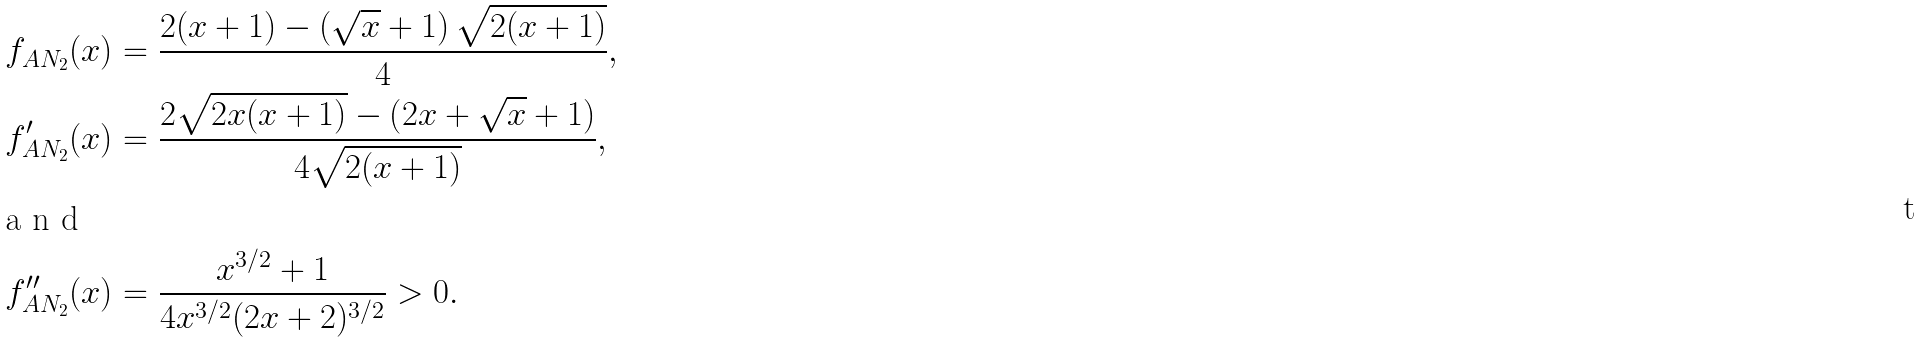<formula> <loc_0><loc_0><loc_500><loc_500>f _ { A N _ { 2 } } ( x ) & = \frac { 2 ( x + 1 ) - \left ( { \sqrt { x } + 1 } \right ) \sqrt { 2 ( x + 1 ) } } { 4 } , \\ { f } ^ { \prime } _ { A N _ { 2 } } ( x ) & = \frac { 2 \sqrt { 2 x ( x + 1 ) } - \left ( { 2 x + \sqrt { x } + 1 } \right ) } { 4 \sqrt { 2 ( x + 1 ) } } , \intertext { a n d } { f } ^ { \prime \prime } _ { A N _ { 2 } } ( x ) & = \frac { x ^ { 3 / 2 } + 1 } { 4 x ^ { 3 / 2 } ( 2 x + 2 ) ^ { 3 / 2 } } > 0 .</formula> 